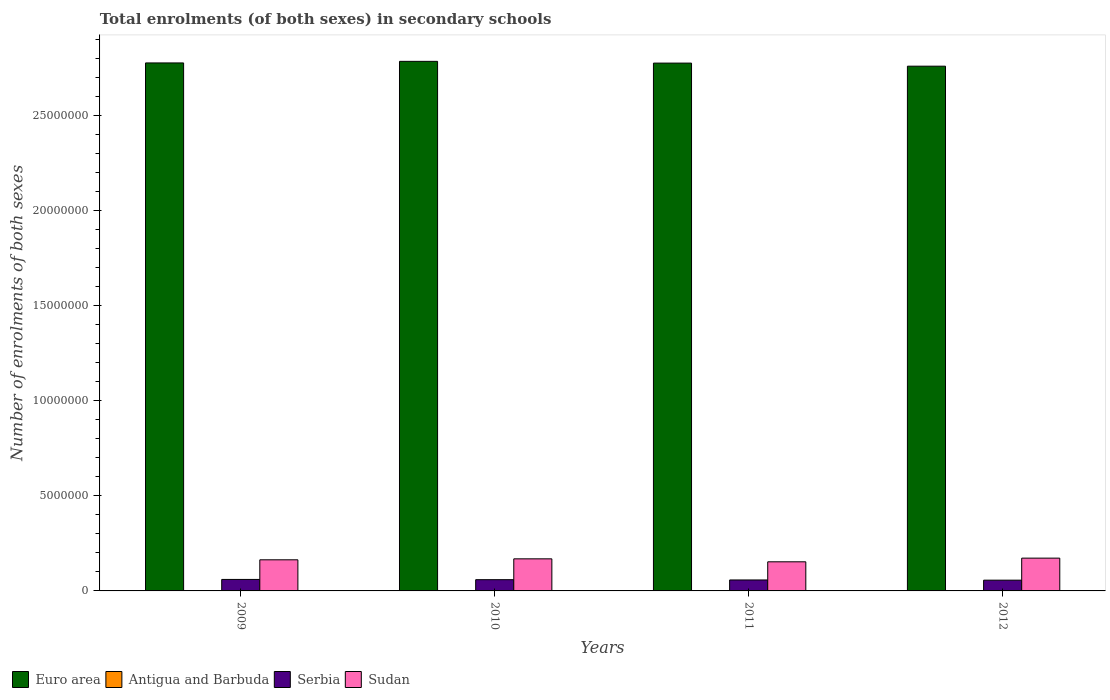How many different coloured bars are there?
Keep it short and to the point. 4. How many groups of bars are there?
Provide a short and direct response. 4. Are the number of bars per tick equal to the number of legend labels?
Your response must be concise. Yes. How many bars are there on the 1st tick from the left?
Give a very brief answer. 4. In how many cases, is the number of bars for a given year not equal to the number of legend labels?
Provide a succinct answer. 0. What is the number of enrolments in secondary schools in Antigua and Barbuda in 2011?
Offer a terse response. 8449. Across all years, what is the maximum number of enrolments in secondary schools in Euro area?
Keep it short and to the point. 2.78e+07. Across all years, what is the minimum number of enrolments in secondary schools in Sudan?
Provide a short and direct response. 1.53e+06. In which year was the number of enrolments in secondary schools in Sudan maximum?
Your answer should be compact. 2012. What is the total number of enrolments in secondary schools in Sudan in the graph?
Offer a very short reply. 6.58e+06. What is the difference between the number of enrolments in secondary schools in Serbia in 2010 and that in 2012?
Your answer should be compact. 2.50e+04. What is the difference between the number of enrolments in secondary schools in Euro area in 2011 and the number of enrolments in secondary schools in Sudan in 2009?
Offer a very short reply. 2.61e+07. What is the average number of enrolments in secondary schools in Antigua and Barbuda per year?
Provide a short and direct response. 8456.25. In the year 2009, what is the difference between the number of enrolments in secondary schools in Antigua and Barbuda and number of enrolments in secondary schools in Sudan?
Provide a short and direct response. -1.63e+06. In how many years, is the number of enrolments in secondary schools in Sudan greater than 4000000?
Provide a short and direct response. 0. What is the ratio of the number of enrolments in secondary schools in Antigua and Barbuda in 2011 to that in 2012?
Provide a succinct answer. 1.01. Is the number of enrolments in secondary schools in Serbia in 2010 less than that in 2011?
Your response must be concise. No. What is the difference between the highest and the second highest number of enrolments in secondary schools in Euro area?
Ensure brevity in your answer.  8.30e+04. What is the difference between the highest and the lowest number of enrolments in secondary schools in Antigua and Barbuda?
Offer a very short reply. 174. Is the sum of the number of enrolments in secondary schools in Serbia in 2009 and 2010 greater than the maximum number of enrolments in secondary schools in Sudan across all years?
Provide a succinct answer. No. What does the 1st bar from the right in 2010 represents?
Your answer should be very brief. Sudan. Are the values on the major ticks of Y-axis written in scientific E-notation?
Your answer should be compact. No. Does the graph contain any zero values?
Your answer should be compact. No. Does the graph contain grids?
Your answer should be compact. No. How many legend labels are there?
Your response must be concise. 4. What is the title of the graph?
Keep it short and to the point. Total enrolments (of both sexes) in secondary schools. What is the label or title of the Y-axis?
Give a very brief answer. Number of enrolments of both sexes. What is the Number of enrolments of both sexes of Euro area in 2009?
Your answer should be very brief. 2.78e+07. What is the Number of enrolments of both sexes of Antigua and Barbuda in 2009?
Your answer should be very brief. 8557. What is the Number of enrolments of both sexes of Serbia in 2009?
Keep it short and to the point. 6.04e+05. What is the Number of enrolments of both sexes in Sudan in 2009?
Keep it short and to the point. 1.64e+06. What is the Number of enrolments of both sexes in Euro area in 2010?
Make the answer very short. 2.78e+07. What is the Number of enrolments of both sexes in Antigua and Barbuda in 2010?
Your answer should be very brief. 8436. What is the Number of enrolments of both sexes of Serbia in 2010?
Keep it short and to the point. 5.91e+05. What is the Number of enrolments of both sexes of Sudan in 2010?
Make the answer very short. 1.69e+06. What is the Number of enrolments of both sexes of Euro area in 2011?
Keep it short and to the point. 2.78e+07. What is the Number of enrolments of both sexes of Antigua and Barbuda in 2011?
Give a very brief answer. 8449. What is the Number of enrolments of both sexes of Serbia in 2011?
Make the answer very short. 5.76e+05. What is the Number of enrolments of both sexes in Sudan in 2011?
Offer a terse response. 1.53e+06. What is the Number of enrolments of both sexes in Euro area in 2012?
Offer a very short reply. 2.76e+07. What is the Number of enrolments of both sexes in Antigua and Barbuda in 2012?
Make the answer very short. 8383. What is the Number of enrolments of both sexes in Serbia in 2012?
Your answer should be very brief. 5.66e+05. What is the Number of enrolments of both sexes in Sudan in 2012?
Your response must be concise. 1.72e+06. Across all years, what is the maximum Number of enrolments of both sexes in Euro area?
Your answer should be very brief. 2.78e+07. Across all years, what is the maximum Number of enrolments of both sexes in Antigua and Barbuda?
Provide a succinct answer. 8557. Across all years, what is the maximum Number of enrolments of both sexes in Serbia?
Offer a terse response. 6.04e+05. Across all years, what is the maximum Number of enrolments of both sexes of Sudan?
Offer a terse response. 1.72e+06. Across all years, what is the minimum Number of enrolments of both sexes in Euro area?
Provide a succinct answer. 2.76e+07. Across all years, what is the minimum Number of enrolments of both sexes of Antigua and Barbuda?
Provide a succinct answer. 8383. Across all years, what is the minimum Number of enrolments of both sexes of Serbia?
Make the answer very short. 5.66e+05. Across all years, what is the minimum Number of enrolments of both sexes of Sudan?
Your response must be concise. 1.53e+06. What is the total Number of enrolments of both sexes of Euro area in the graph?
Ensure brevity in your answer.  1.11e+08. What is the total Number of enrolments of both sexes in Antigua and Barbuda in the graph?
Your answer should be very brief. 3.38e+04. What is the total Number of enrolments of both sexes of Serbia in the graph?
Your answer should be compact. 2.34e+06. What is the total Number of enrolments of both sexes of Sudan in the graph?
Your answer should be very brief. 6.58e+06. What is the difference between the Number of enrolments of both sexes in Euro area in 2009 and that in 2010?
Offer a very short reply. -8.30e+04. What is the difference between the Number of enrolments of both sexes in Antigua and Barbuda in 2009 and that in 2010?
Your answer should be very brief. 121. What is the difference between the Number of enrolments of both sexes of Serbia in 2009 and that in 2010?
Your response must be concise. 1.30e+04. What is the difference between the Number of enrolments of both sexes of Sudan in 2009 and that in 2010?
Your answer should be compact. -5.13e+04. What is the difference between the Number of enrolments of both sexes in Euro area in 2009 and that in 2011?
Provide a succinct answer. 8550. What is the difference between the Number of enrolments of both sexes in Antigua and Barbuda in 2009 and that in 2011?
Your answer should be compact. 108. What is the difference between the Number of enrolments of both sexes of Serbia in 2009 and that in 2011?
Your answer should be very brief. 2.79e+04. What is the difference between the Number of enrolments of both sexes in Sudan in 2009 and that in 2011?
Offer a very short reply. 1.05e+05. What is the difference between the Number of enrolments of both sexes in Euro area in 2009 and that in 2012?
Offer a terse response. 1.71e+05. What is the difference between the Number of enrolments of both sexes in Antigua and Barbuda in 2009 and that in 2012?
Keep it short and to the point. 174. What is the difference between the Number of enrolments of both sexes in Serbia in 2009 and that in 2012?
Keep it short and to the point. 3.80e+04. What is the difference between the Number of enrolments of both sexes of Sudan in 2009 and that in 2012?
Your answer should be very brief. -8.77e+04. What is the difference between the Number of enrolments of both sexes of Euro area in 2010 and that in 2011?
Your answer should be compact. 9.16e+04. What is the difference between the Number of enrolments of both sexes of Antigua and Barbuda in 2010 and that in 2011?
Provide a short and direct response. -13. What is the difference between the Number of enrolments of both sexes in Serbia in 2010 and that in 2011?
Your response must be concise. 1.49e+04. What is the difference between the Number of enrolments of both sexes in Sudan in 2010 and that in 2011?
Make the answer very short. 1.57e+05. What is the difference between the Number of enrolments of both sexes in Euro area in 2010 and that in 2012?
Provide a succinct answer. 2.54e+05. What is the difference between the Number of enrolments of both sexes in Serbia in 2010 and that in 2012?
Make the answer very short. 2.50e+04. What is the difference between the Number of enrolments of both sexes of Sudan in 2010 and that in 2012?
Offer a terse response. -3.63e+04. What is the difference between the Number of enrolments of both sexes in Euro area in 2011 and that in 2012?
Ensure brevity in your answer.  1.63e+05. What is the difference between the Number of enrolments of both sexes in Serbia in 2011 and that in 2012?
Your response must be concise. 1.01e+04. What is the difference between the Number of enrolments of both sexes in Sudan in 2011 and that in 2012?
Ensure brevity in your answer.  -1.93e+05. What is the difference between the Number of enrolments of both sexes in Euro area in 2009 and the Number of enrolments of both sexes in Antigua and Barbuda in 2010?
Provide a succinct answer. 2.78e+07. What is the difference between the Number of enrolments of both sexes of Euro area in 2009 and the Number of enrolments of both sexes of Serbia in 2010?
Provide a short and direct response. 2.72e+07. What is the difference between the Number of enrolments of both sexes of Euro area in 2009 and the Number of enrolments of both sexes of Sudan in 2010?
Provide a succinct answer. 2.61e+07. What is the difference between the Number of enrolments of both sexes in Antigua and Barbuda in 2009 and the Number of enrolments of both sexes in Serbia in 2010?
Offer a very short reply. -5.82e+05. What is the difference between the Number of enrolments of both sexes of Antigua and Barbuda in 2009 and the Number of enrolments of both sexes of Sudan in 2010?
Your answer should be compact. -1.68e+06. What is the difference between the Number of enrolments of both sexes in Serbia in 2009 and the Number of enrolments of both sexes in Sudan in 2010?
Offer a terse response. -1.08e+06. What is the difference between the Number of enrolments of both sexes of Euro area in 2009 and the Number of enrolments of both sexes of Antigua and Barbuda in 2011?
Ensure brevity in your answer.  2.78e+07. What is the difference between the Number of enrolments of both sexes in Euro area in 2009 and the Number of enrolments of both sexes in Serbia in 2011?
Keep it short and to the point. 2.72e+07. What is the difference between the Number of enrolments of both sexes of Euro area in 2009 and the Number of enrolments of both sexes of Sudan in 2011?
Ensure brevity in your answer.  2.62e+07. What is the difference between the Number of enrolments of both sexes of Antigua and Barbuda in 2009 and the Number of enrolments of both sexes of Serbia in 2011?
Provide a succinct answer. -5.67e+05. What is the difference between the Number of enrolments of both sexes of Antigua and Barbuda in 2009 and the Number of enrolments of both sexes of Sudan in 2011?
Provide a succinct answer. -1.52e+06. What is the difference between the Number of enrolments of both sexes of Serbia in 2009 and the Number of enrolments of both sexes of Sudan in 2011?
Your answer should be compact. -9.27e+05. What is the difference between the Number of enrolments of both sexes of Euro area in 2009 and the Number of enrolments of both sexes of Antigua and Barbuda in 2012?
Offer a terse response. 2.78e+07. What is the difference between the Number of enrolments of both sexes of Euro area in 2009 and the Number of enrolments of both sexes of Serbia in 2012?
Make the answer very short. 2.72e+07. What is the difference between the Number of enrolments of both sexes of Euro area in 2009 and the Number of enrolments of both sexes of Sudan in 2012?
Your answer should be very brief. 2.60e+07. What is the difference between the Number of enrolments of both sexes of Antigua and Barbuda in 2009 and the Number of enrolments of both sexes of Serbia in 2012?
Ensure brevity in your answer.  -5.57e+05. What is the difference between the Number of enrolments of both sexes of Antigua and Barbuda in 2009 and the Number of enrolments of both sexes of Sudan in 2012?
Provide a short and direct response. -1.72e+06. What is the difference between the Number of enrolments of both sexes of Serbia in 2009 and the Number of enrolments of both sexes of Sudan in 2012?
Your answer should be very brief. -1.12e+06. What is the difference between the Number of enrolments of both sexes of Euro area in 2010 and the Number of enrolments of both sexes of Antigua and Barbuda in 2011?
Make the answer very short. 2.78e+07. What is the difference between the Number of enrolments of both sexes of Euro area in 2010 and the Number of enrolments of both sexes of Serbia in 2011?
Your response must be concise. 2.73e+07. What is the difference between the Number of enrolments of both sexes of Euro area in 2010 and the Number of enrolments of both sexes of Sudan in 2011?
Provide a succinct answer. 2.63e+07. What is the difference between the Number of enrolments of both sexes in Antigua and Barbuda in 2010 and the Number of enrolments of both sexes in Serbia in 2011?
Ensure brevity in your answer.  -5.68e+05. What is the difference between the Number of enrolments of both sexes of Antigua and Barbuda in 2010 and the Number of enrolments of both sexes of Sudan in 2011?
Your answer should be compact. -1.52e+06. What is the difference between the Number of enrolments of both sexes in Serbia in 2010 and the Number of enrolments of both sexes in Sudan in 2011?
Your response must be concise. -9.40e+05. What is the difference between the Number of enrolments of both sexes of Euro area in 2010 and the Number of enrolments of both sexes of Antigua and Barbuda in 2012?
Offer a very short reply. 2.78e+07. What is the difference between the Number of enrolments of both sexes in Euro area in 2010 and the Number of enrolments of both sexes in Serbia in 2012?
Your answer should be very brief. 2.73e+07. What is the difference between the Number of enrolments of both sexes in Euro area in 2010 and the Number of enrolments of both sexes in Sudan in 2012?
Offer a very short reply. 2.61e+07. What is the difference between the Number of enrolments of both sexes in Antigua and Barbuda in 2010 and the Number of enrolments of both sexes in Serbia in 2012?
Give a very brief answer. -5.57e+05. What is the difference between the Number of enrolments of both sexes of Antigua and Barbuda in 2010 and the Number of enrolments of both sexes of Sudan in 2012?
Provide a succinct answer. -1.72e+06. What is the difference between the Number of enrolments of both sexes in Serbia in 2010 and the Number of enrolments of both sexes in Sudan in 2012?
Your response must be concise. -1.13e+06. What is the difference between the Number of enrolments of both sexes in Euro area in 2011 and the Number of enrolments of both sexes in Antigua and Barbuda in 2012?
Your response must be concise. 2.77e+07. What is the difference between the Number of enrolments of both sexes of Euro area in 2011 and the Number of enrolments of both sexes of Serbia in 2012?
Keep it short and to the point. 2.72e+07. What is the difference between the Number of enrolments of both sexes of Euro area in 2011 and the Number of enrolments of both sexes of Sudan in 2012?
Provide a succinct answer. 2.60e+07. What is the difference between the Number of enrolments of both sexes in Antigua and Barbuda in 2011 and the Number of enrolments of both sexes in Serbia in 2012?
Make the answer very short. -5.57e+05. What is the difference between the Number of enrolments of both sexes in Antigua and Barbuda in 2011 and the Number of enrolments of both sexes in Sudan in 2012?
Ensure brevity in your answer.  -1.72e+06. What is the difference between the Number of enrolments of both sexes in Serbia in 2011 and the Number of enrolments of both sexes in Sudan in 2012?
Give a very brief answer. -1.15e+06. What is the average Number of enrolments of both sexes in Euro area per year?
Your answer should be compact. 2.77e+07. What is the average Number of enrolments of both sexes of Antigua and Barbuda per year?
Your response must be concise. 8456.25. What is the average Number of enrolments of both sexes in Serbia per year?
Provide a short and direct response. 5.84e+05. What is the average Number of enrolments of both sexes in Sudan per year?
Offer a terse response. 1.64e+06. In the year 2009, what is the difference between the Number of enrolments of both sexes of Euro area and Number of enrolments of both sexes of Antigua and Barbuda?
Your answer should be compact. 2.78e+07. In the year 2009, what is the difference between the Number of enrolments of both sexes of Euro area and Number of enrolments of both sexes of Serbia?
Your answer should be compact. 2.72e+07. In the year 2009, what is the difference between the Number of enrolments of both sexes in Euro area and Number of enrolments of both sexes in Sudan?
Your answer should be very brief. 2.61e+07. In the year 2009, what is the difference between the Number of enrolments of both sexes in Antigua and Barbuda and Number of enrolments of both sexes in Serbia?
Give a very brief answer. -5.95e+05. In the year 2009, what is the difference between the Number of enrolments of both sexes in Antigua and Barbuda and Number of enrolments of both sexes in Sudan?
Offer a terse response. -1.63e+06. In the year 2009, what is the difference between the Number of enrolments of both sexes in Serbia and Number of enrolments of both sexes in Sudan?
Make the answer very short. -1.03e+06. In the year 2010, what is the difference between the Number of enrolments of both sexes in Euro area and Number of enrolments of both sexes in Antigua and Barbuda?
Your response must be concise. 2.78e+07. In the year 2010, what is the difference between the Number of enrolments of both sexes in Euro area and Number of enrolments of both sexes in Serbia?
Make the answer very short. 2.73e+07. In the year 2010, what is the difference between the Number of enrolments of both sexes of Euro area and Number of enrolments of both sexes of Sudan?
Your answer should be compact. 2.62e+07. In the year 2010, what is the difference between the Number of enrolments of both sexes of Antigua and Barbuda and Number of enrolments of both sexes of Serbia?
Your answer should be very brief. -5.82e+05. In the year 2010, what is the difference between the Number of enrolments of both sexes in Antigua and Barbuda and Number of enrolments of both sexes in Sudan?
Offer a terse response. -1.68e+06. In the year 2010, what is the difference between the Number of enrolments of both sexes in Serbia and Number of enrolments of both sexes in Sudan?
Ensure brevity in your answer.  -1.10e+06. In the year 2011, what is the difference between the Number of enrolments of both sexes in Euro area and Number of enrolments of both sexes in Antigua and Barbuda?
Offer a very short reply. 2.77e+07. In the year 2011, what is the difference between the Number of enrolments of both sexes in Euro area and Number of enrolments of both sexes in Serbia?
Offer a very short reply. 2.72e+07. In the year 2011, what is the difference between the Number of enrolments of both sexes of Euro area and Number of enrolments of both sexes of Sudan?
Provide a short and direct response. 2.62e+07. In the year 2011, what is the difference between the Number of enrolments of both sexes of Antigua and Barbuda and Number of enrolments of both sexes of Serbia?
Offer a terse response. -5.67e+05. In the year 2011, what is the difference between the Number of enrolments of both sexes of Antigua and Barbuda and Number of enrolments of both sexes of Sudan?
Offer a very short reply. -1.52e+06. In the year 2011, what is the difference between the Number of enrolments of both sexes in Serbia and Number of enrolments of both sexes in Sudan?
Give a very brief answer. -9.55e+05. In the year 2012, what is the difference between the Number of enrolments of both sexes in Euro area and Number of enrolments of both sexes in Antigua and Barbuda?
Ensure brevity in your answer.  2.76e+07. In the year 2012, what is the difference between the Number of enrolments of both sexes of Euro area and Number of enrolments of both sexes of Serbia?
Your answer should be compact. 2.70e+07. In the year 2012, what is the difference between the Number of enrolments of both sexes in Euro area and Number of enrolments of both sexes in Sudan?
Provide a short and direct response. 2.59e+07. In the year 2012, what is the difference between the Number of enrolments of both sexes of Antigua and Barbuda and Number of enrolments of both sexes of Serbia?
Your answer should be very brief. -5.57e+05. In the year 2012, what is the difference between the Number of enrolments of both sexes of Antigua and Barbuda and Number of enrolments of both sexes of Sudan?
Your response must be concise. -1.72e+06. In the year 2012, what is the difference between the Number of enrolments of both sexes in Serbia and Number of enrolments of both sexes in Sudan?
Give a very brief answer. -1.16e+06. What is the ratio of the Number of enrolments of both sexes of Antigua and Barbuda in 2009 to that in 2010?
Your response must be concise. 1.01. What is the ratio of the Number of enrolments of both sexes in Serbia in 2009 to that in 2010?
Make the answer very short. 1.02. What is the ratio of the Number of enrolments of both sexes in Sudan in 2009 to that in 2010?
Keep it short and to the point. 0.97. What is the ratio of the Number of enrolments of both sexes of Antigua and Barbuda in 2009 to that in 2011?
Ensure brevity in your answer.  1.01. What is the ratio of the Number of enrolments of both sexes in Serbia in 2009 to that in 2011?
Your answer should be very brief. 1.05. What is the ratio of the Number of enrolments of both sexes of Sudan in 2009 to that in 2011?
Offer a terse response. 1.07. What is the ratio of the Number of enrolments of both sexes of Antigua and Barbuda in 2009 to that in 2012?
Make the answer very short. 1.02. What is the ratio of the Number of enrolments of both sexes in Serbia in 2009 to that in 2012?
Your answer should be compact. 1.07. What is the ratio of the Number of enrolments of both sexes in Sudan in 2009 to that in 2012?
Give a very brief answer. 0.95. What is the ratio of the Number of enrolments of both sexes in Antigua and Barbuda in 2010 to that in 2011?
Offer a very short reply. 1. What is the ratio of the Number of enrolments of both sexes in Serbia in 2010 to that in 2011?
Provide a short and direct response. 1.03. What is the ratio of the Number of enrolments of both sexes in Sudan in 2010 to that in 2011?
Your answer should be very brief. 1.1. What is the ratio of the Number of enrolments of both sexes in Euro area in 2010 to that in 2012?
Your answer should be very brief. 1.01. What is the ratio of the Number of enrolments of both sexes in Antigua and Barbuda in 2010 to that in 2012?
Ensure brevity in your answer.  1.01. What is the ratio of the Number of enrolments of both sexes in Serbia in 2010 to that in 2012?
Your answer should be compact. 1.04. What is the ratio of the Number of enrolments of both sexes of Sudan in 2010 to that in 2012?
Provide a succinct answer. 0.98. What is the ratio of the Number of enrolments of both sexes of Euro area in 2011 to that in 2012?
Offer a terse response. 1.01. What is the ratio of the Number of enrolments of both sexes of Antigua and Barbuda in 2011 to that in 2012?
Keep it short and to the point. 1.01. What is the ratio of the Number of enrolments of both sexes of Serbia in 2011 to that in 2012?
Your answer should be compact. 1.02. What is the ratio of the Number of enrolments of both sexes in Sudan in 2011 to that in 2012?
Provide a short and direct response. 0.89. What is the difference between the highest and the second highest Number of enrolments of both sexes in Euro area?
Provide a short and direct response. 8.30e+04. What is the difference between the highest and the second highest Number of enrolments of both sexes in Antigua and Barbuda?
Your answer should be very brief. 108. What is the difference between the highest and the second highest Number of enrolments of both sexes in Serbia?
Offer a very short reply. 1.30e+04. What is the difference between the highest and the second highest Number of enrolments of both sexes of Sudan?
Keep it short and to the point. 3.63e+04. What is the difference between the highest and the lowest Number of enrolments of both sexes in Euro area?
Keep it short and to the point. 2.54e+05. What is the difference between the highest and the lowest Number of enrolments of both sexes of Antigua and Barbuda?
Your answer should be compact. 174. What is the difference between the highest and the lowest Number of enrolments of both sexes of Serbia?
Provide a succinct answer. 3.80e+04. What is the difference between the highest and the lowest Number of enrolments of both sexes in Sudan?
Offer a terse response. 1.93e+05. 